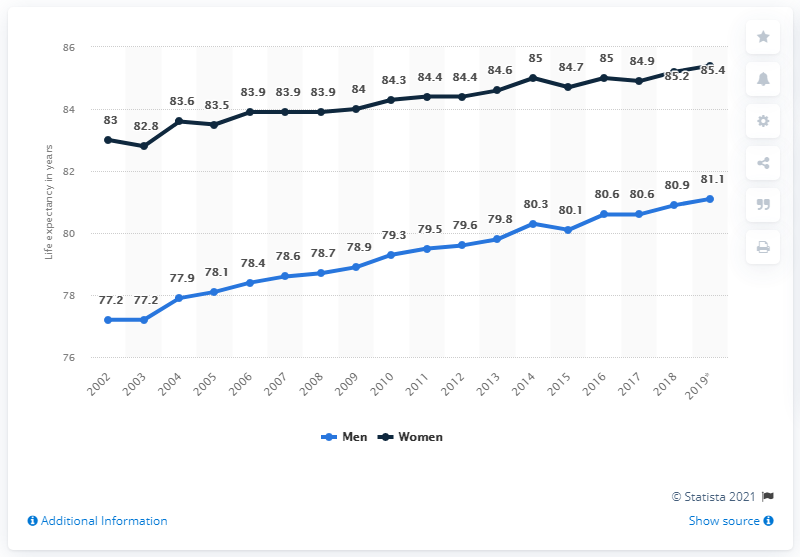Give some essential details in this illustration. In the year 2002, life expectancy at birth in Italy increased. 